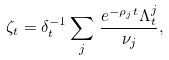<formula> <loc_0><loc_0><loc_500><loc_500>\zeta _ { t } = \delta _ { t } ^ { - 1 } \sum _ { j } \, \frac { e ^ { - \rho _ { j } t } \Lambda _ { t } ^ { j } } { \nu _ { j } } ,</formula> 